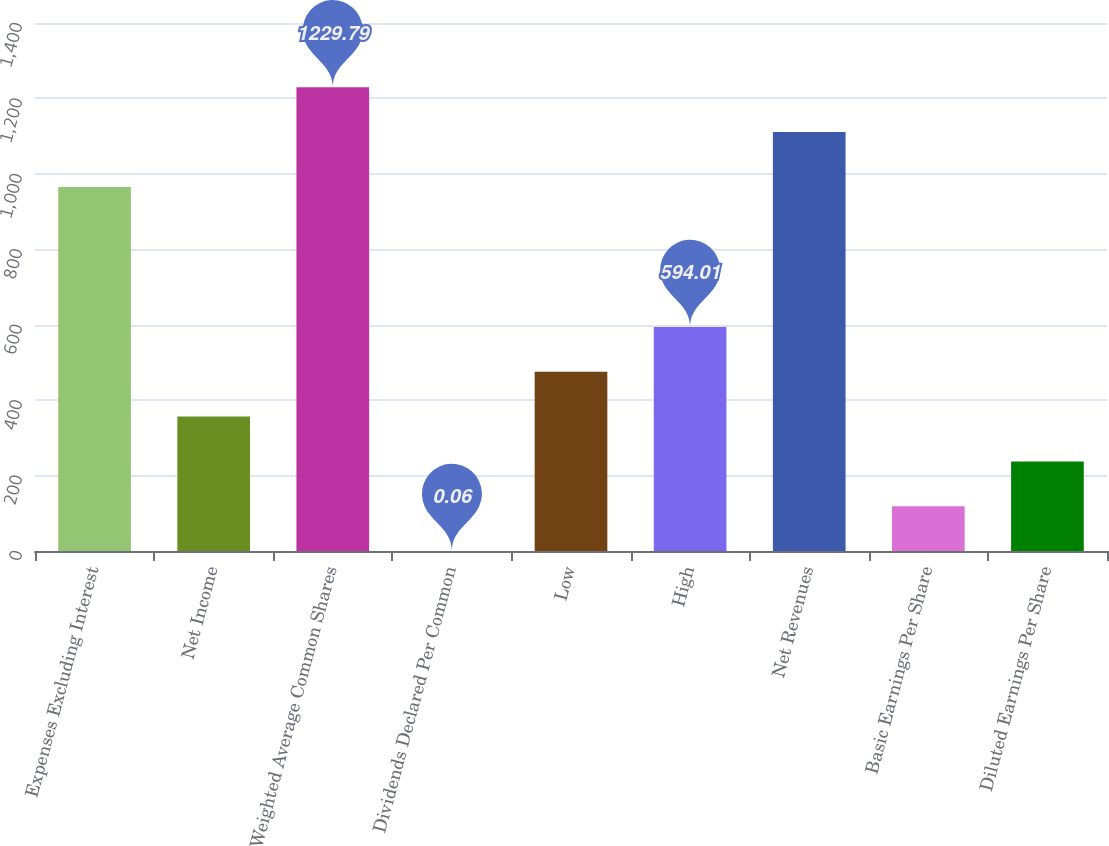Convert chart. <chart><loc_0><loc_0><loc_500><loc_500><bar_chart><fcel>Expenses Excluding Interest<fcel>Net Income<fcel>Weighted Average Common Shares<fcel>Dividends Declared Per Common<fcel>Low<fcel>High<fcel>Net Revenues<fcel>Basic Earnings Per Share<fcel>Diluted Earnings Per Share<nl><fcel>965<fcel>356.43<fcel>1229.79<fcel>0.06<fcel>475.22<fcel>594.01<fcel>1111<fcel>118.85<fcel>237.64<nl></chart> 